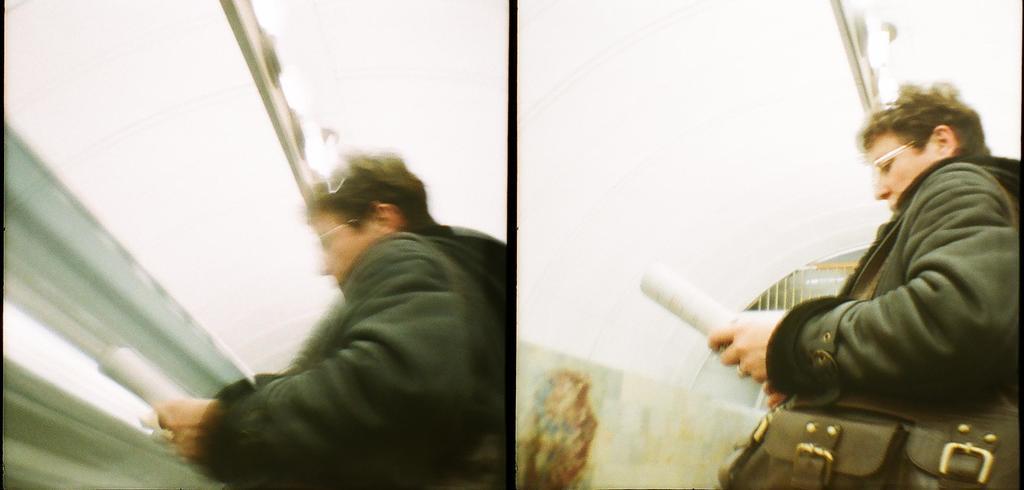Could you give a brief overview of what you see in this image? In this picture there is a woman standing and holding an object in her hands and in this picture there is a woman who has spectacles, standing and holding an object in her left hand, there is a ring to her finger and she is wearing a handbag. 